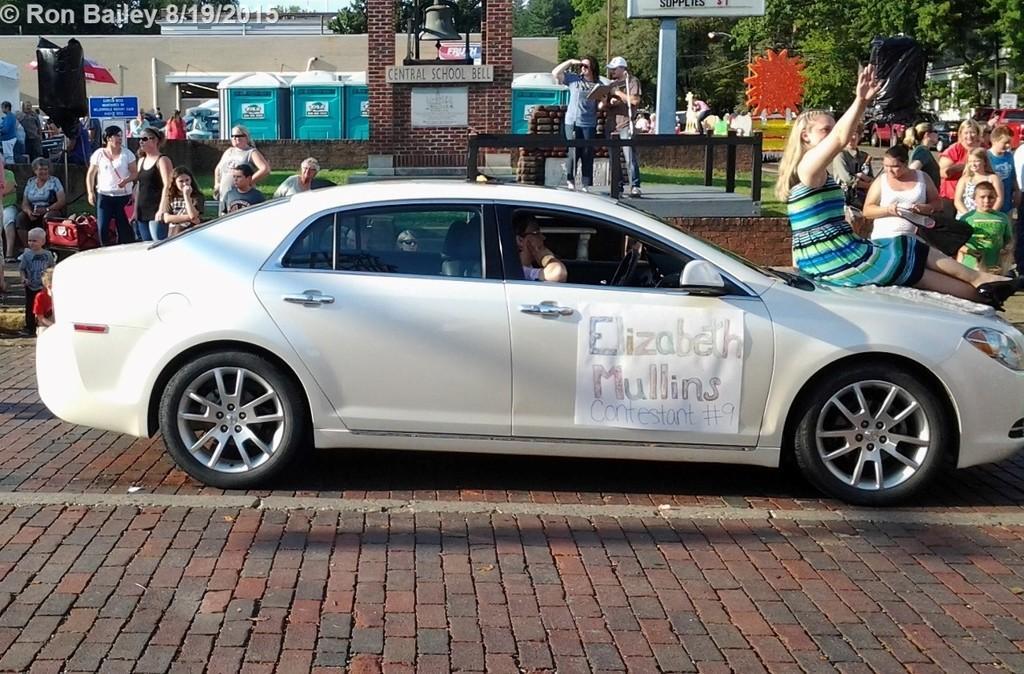Can you describe this image briefly? In this picture there is a man who is sitting inside the car. There is a poster which is attached on the car´s door. There is a woman who is a sitting on the car's bonnet. On the right i can see the group of persons were standing near to the wall. On the left i can see another group of persons were standing near to black object and some people were sitting on the bench. In the background i can see the building, trees, cars, steel box & boards. In the top left corner there is a watermark. At the top there is a sky. 